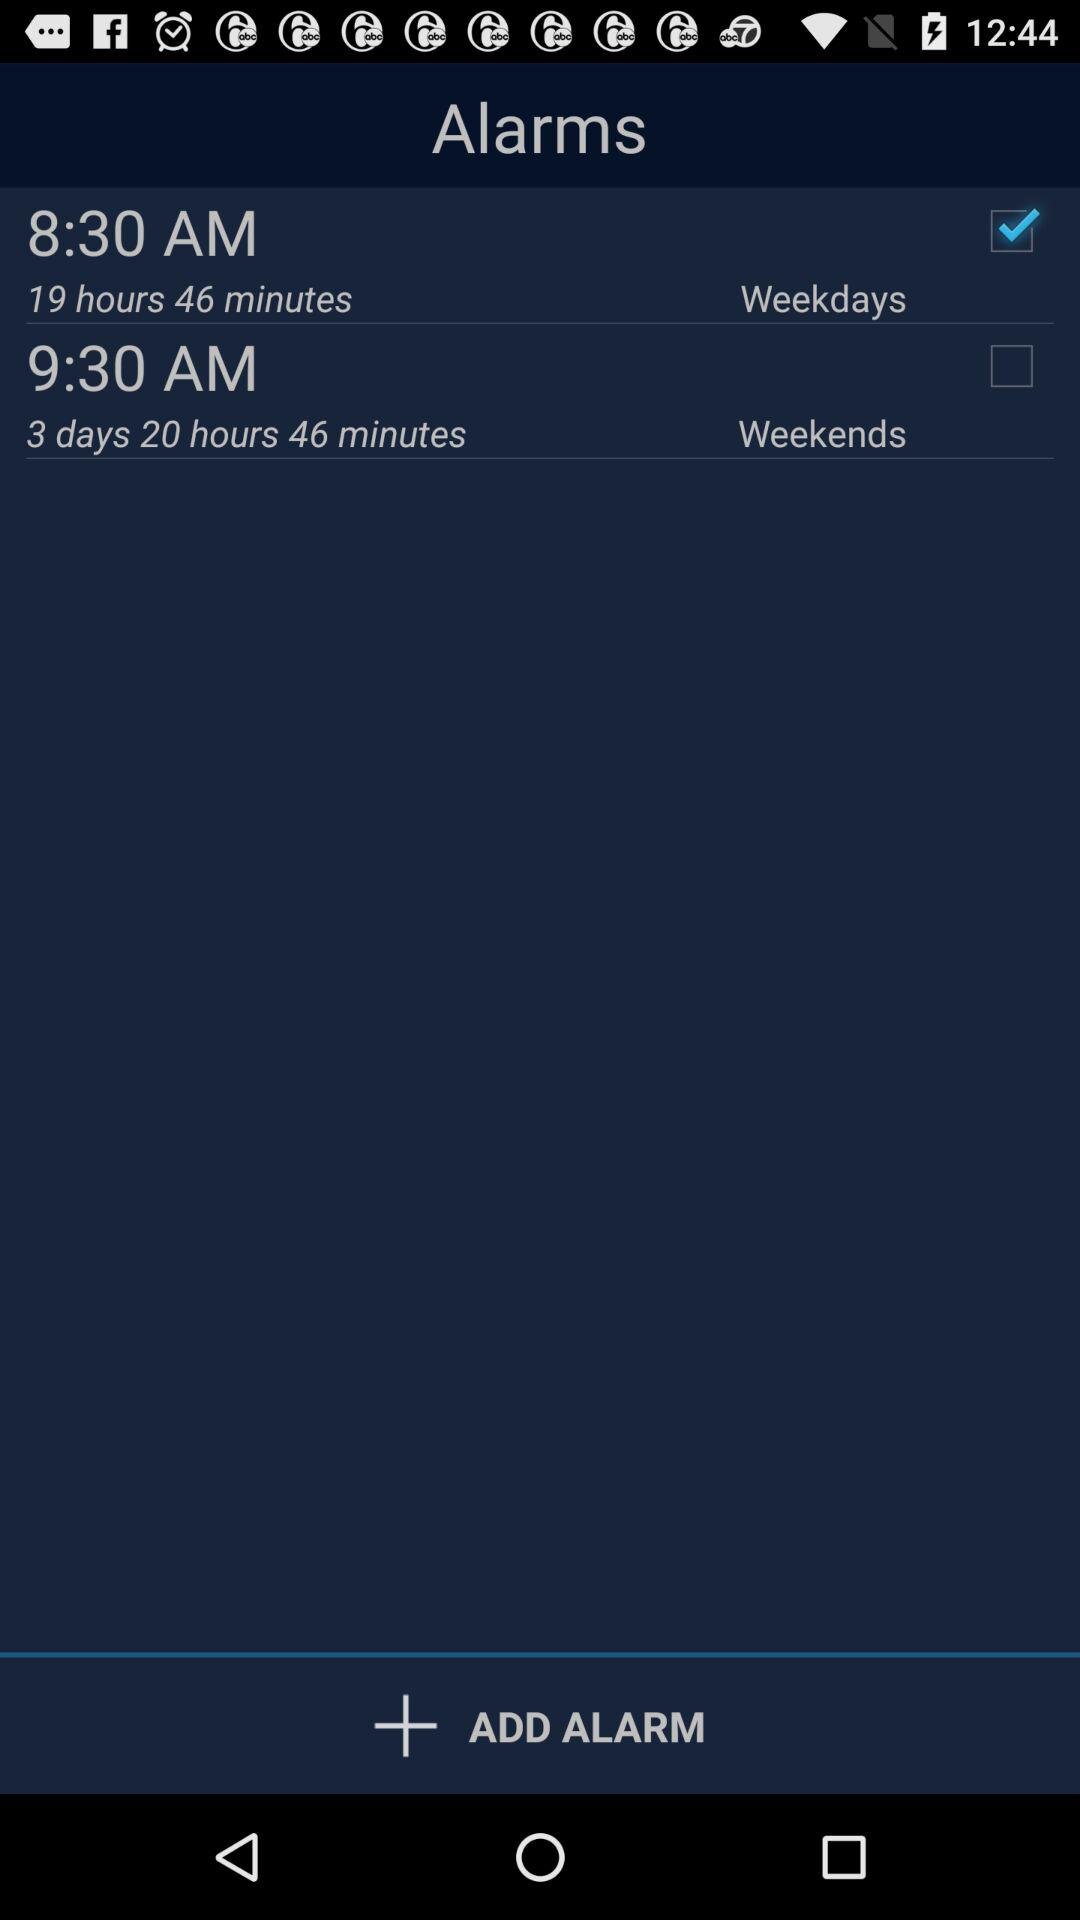What is the alarm time on the weekends? The alarm time is 9:30 AM. 